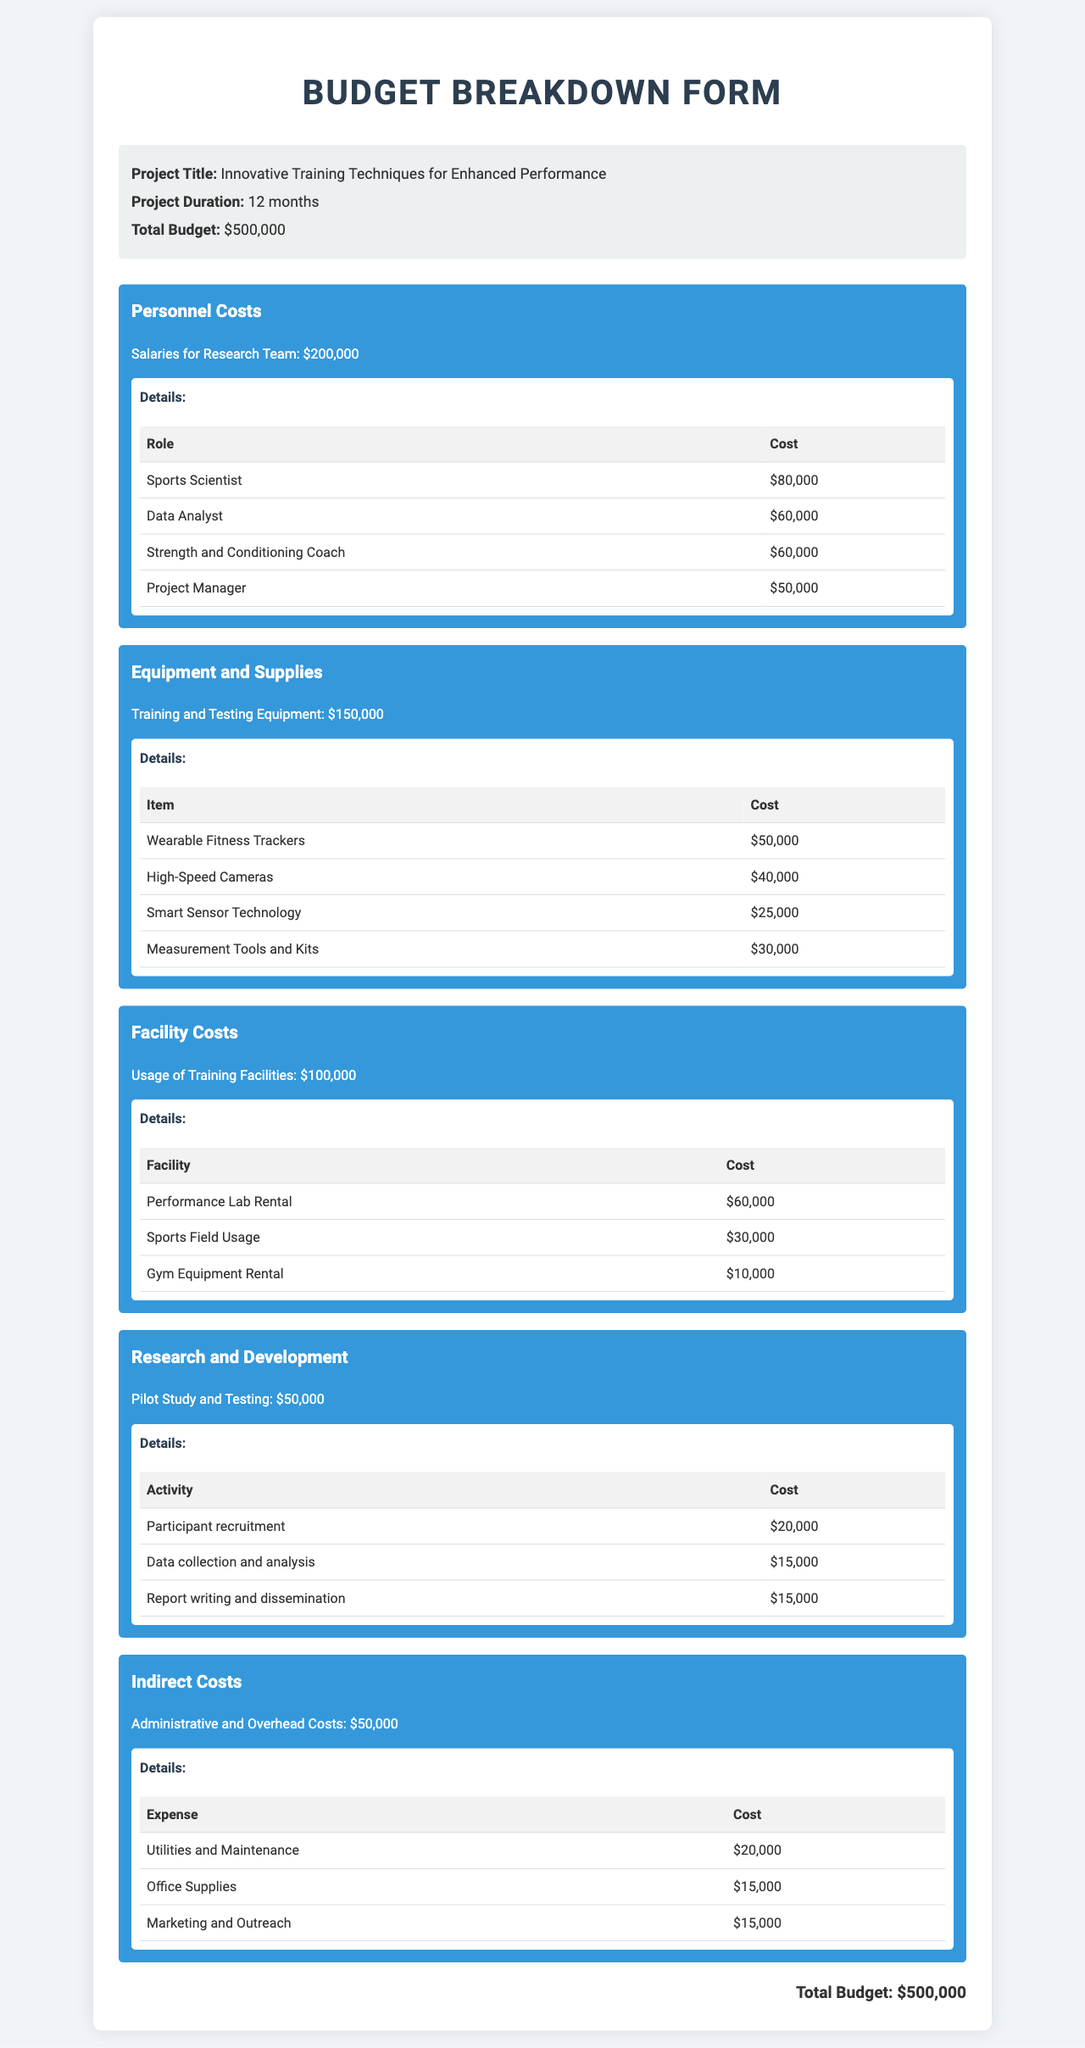what is the project title? The project title is clearly stated in the document under "Project Title."
Answer: Innovative Training Techniques for Enhanced Performance what is the total budget allocated? The total budget allocated is found under "Total Budget."
Answer: $500,000 how much is allocated for Personnel Costs? The allocation for Personnel Costs is mentioned in the relevant section of the document.
Answer: $200,000 who is the Sports Scientist? The Sports Scientist is listed under "Personnel Costs" in the roles and costs table.
Answer: $80,000 how much is budgeted for Equipment and Supplies? The budget for Equipment and Supplies is specified in the corresponding section.
Answer: $150,000 what are the total costs for Facility Costs? The total costs for Facility Costs are detailed within its section of the document.
Answer: $100,000 how much is planned for the Pilot Study and Testing? The planned budget for the Pilot Study and Testing is indicated within the Research and Development section.
Answer: $50,000 what is the cost for Utilities and Maintenance? The cost for Utilities and Maintenance is detailed under Indirect Costs in the expenses table.
Answer: $20,000 how many months will the project last? The duration of the project is mentioned directly in the project information.
Answer: 12 months 